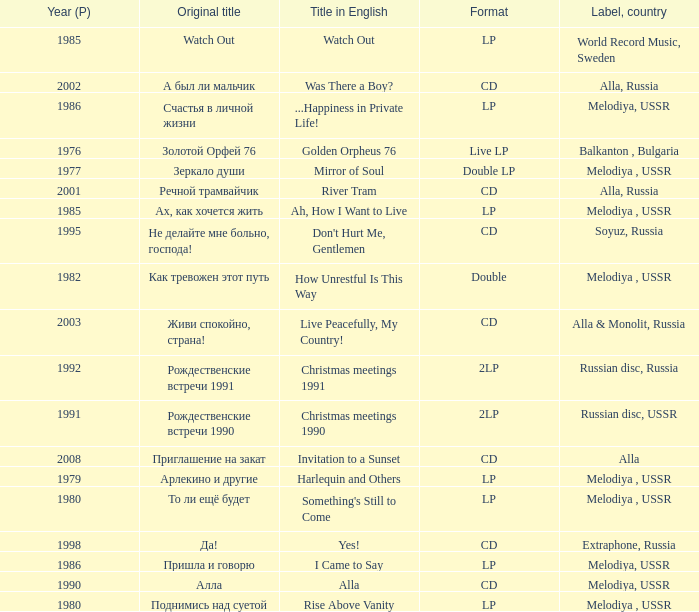What is the english title with a lp format and an Original title of то ли ещё будет? Something's Still to Come. 